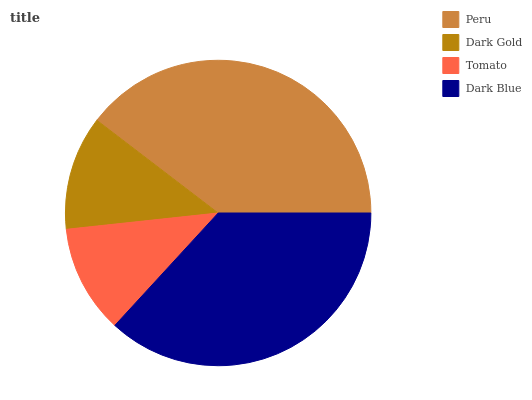Is Tomato the minimum?
Answer yes or no. Yes. Is Peru the maximum?
Answer yes or no. Yes. Is Dark Gold the minimum?
Answer yes or no. No. Is Dark Gold the maximum?
Answer yes or no. No. Is Peru greater than Dark Gold?
Answer yes or no. Yes. Is Dark Gold less than Peru?
Answer yes or no. Yes. Is Dark Gold greater than Peru?
Answer yes or no. No. Is Peru less than Dark Gold?
Answer yes or no. No. Is Dark Blue the high median?
Answer yes or no. Yes. Is Dark Gold the low median?
Answer yes or no. Yes. Is Dark Gold the high median?
Answer yes or no. No. Is Dark Blue the low median?
Answer yes or no. No. 